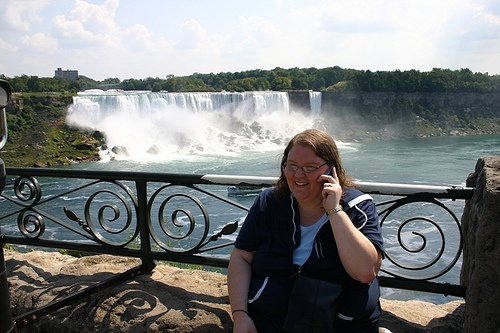Describe the objects in this image and their specific colors. I can see people in lightgray, black, gray, maroon, and brown tones and cell phone in lightgray, black, navy, purple, and maroon tones in this image. 